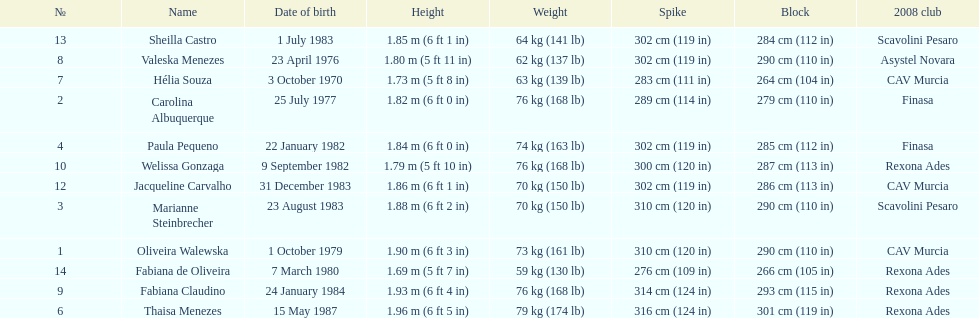Who is the next tallest player after thaisa menezes? Fabiana Claudino. 